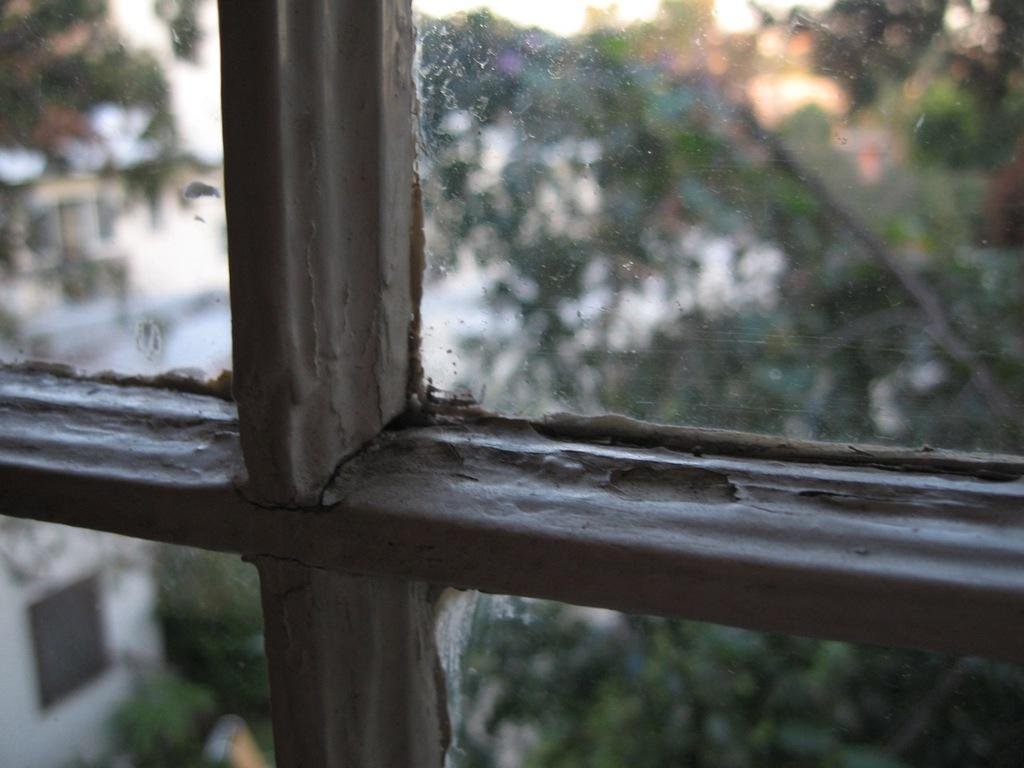What type of structure is present in the image? There is a glass window in the image. What can be seen through the window? Trees are visible through the window. How would you describe the quality of the image? The image is slightly blurred. Reasoning: Let's think step by step by step in order to produce the conversation. We start by identifying the main subject in the image, which is the glass window. Then, we expand the conversation to include what can be seen through the window, which is the trees. Finally, we address the quality of the image, noting that it is slightly blurred. Each question is designed to elicit a specific detail about the image that is known from the provided facts. Absurd Question/Answer: What type of board is being used to create a metal rest in the image? There is no board or metal rest present in the image. What type of board is being used to create a metal rest in the image? There is no board or metal rest present in the image. 